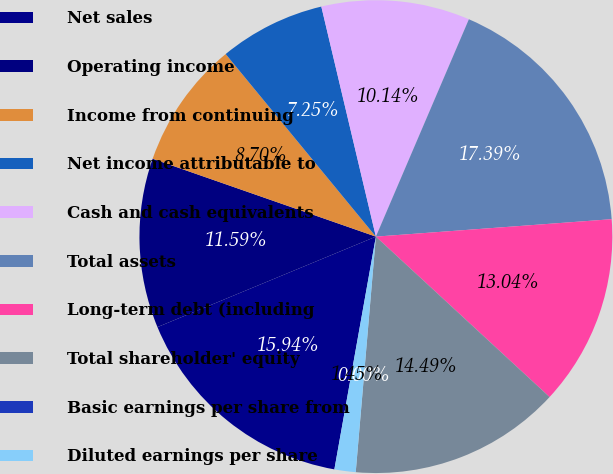Convert chart to OTSL. <chart><loc_0><loc_0><loc_500><loc_500><pie_chart><fcel>Net sales<fcel>Operating income<fcel>Income from continuing<fcel>Net income attributable to<fcel>Cash and cash equivalents<fcel>Total assets<fcel>Long-term debt (including<fcel>Total shareholder' equity<fcel>Basic earnings per share from<fcel>Diluted earnings per share<nl><fcel>15.94%<fcel>11.59%<fcel>8.7%<fcel>7.25%<fcel>10.14%<fcel>17.39%<fcel>13.04%<fcel>14.49%<fcel>0.0%<fcel>1.45%<nl></chart> 